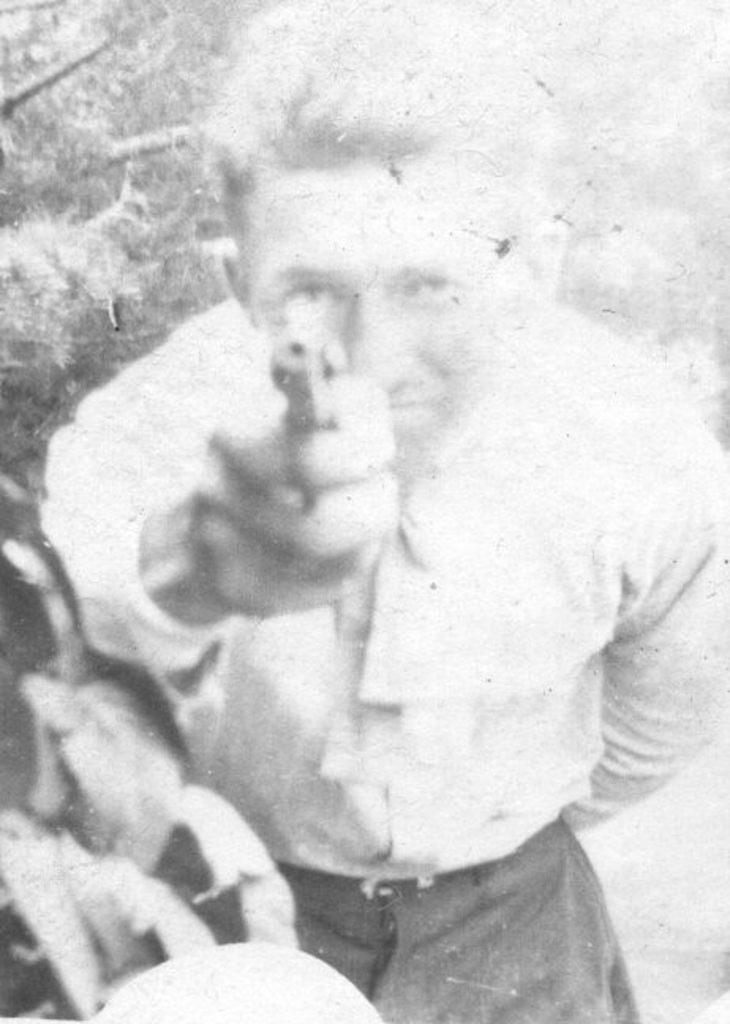Can you describe this image briefly? This is a black and white pic. In this image we can see a man is holding an object in his hand. In the background there are trees. 